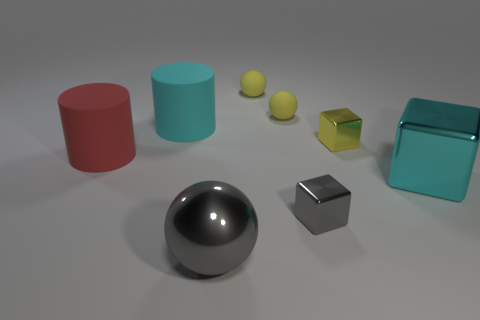How many other things are the same color as the large block?
Keep it short and to the point. 1. What size is the rubber cylinder that is the same color as the big cube?
Make the answer very short. Large. What is the material of the small block that is the same color as the big metallic sphere?
Ensure brevity in your answer.  Metal. There is a tiny metal object that is the same color as the metal sphere; what is its shape?
Make the answer very short. Cube. What is the shape of the other metallic object that is the same size as the yellow shiny thing?
Provide a short and direct response. Cube. Does the cyan thing left of the yellow metallic thing have the same material as the large gray sphere that is in front of the cyan cylinder?
Give a very brief answer. No. What number of green balls are there?
Provide a succinct answer. 0. How many large metal objects are the same shape as the cyan rubber thing?
Make the answer very short. 0. Is the shape of the big red rubber thing the same as the big cyan shiny thing?
Offer a terse response. No. What is the size of the red object?
Offer a very short reply. Large. 